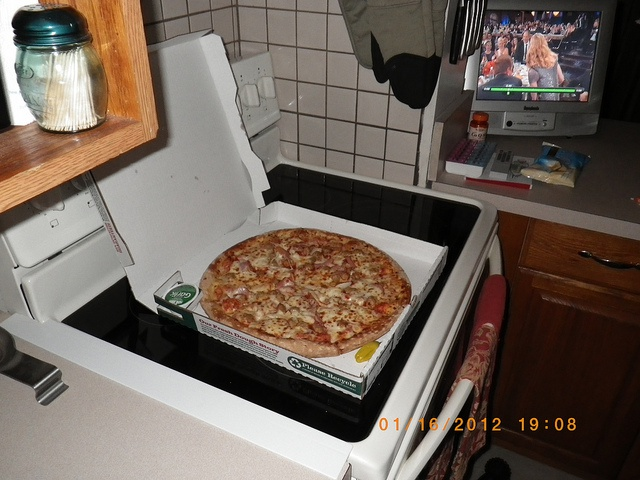Describe the objects in this image and their specific colors. I can see oven in white, darkgray, black, gray, and maroon tones, pizza in white, gray, maroon, and brown tones, tv in white, black, gray, and darkgray tones, bottle in white, ivory, black, darkgray, and tan tones, and remote in white, black, and gray tones in this image. 